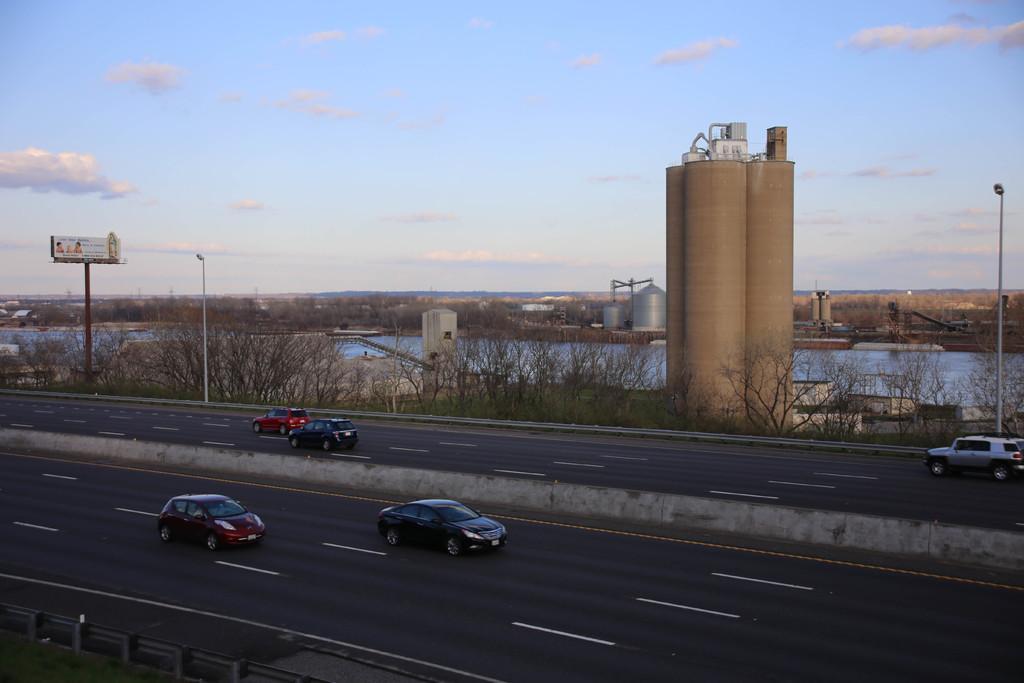In one or two sentences, can you explain what this image depicts? In this picture we can see vehicles on roads, trees, silos, poles, hoarding, lights, grass and water. In the background of the image we can see the sky. 